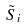<formula> <loc_0><loc_0><loc_500><loc_500>\tilde { S } _ { i }</formula> 